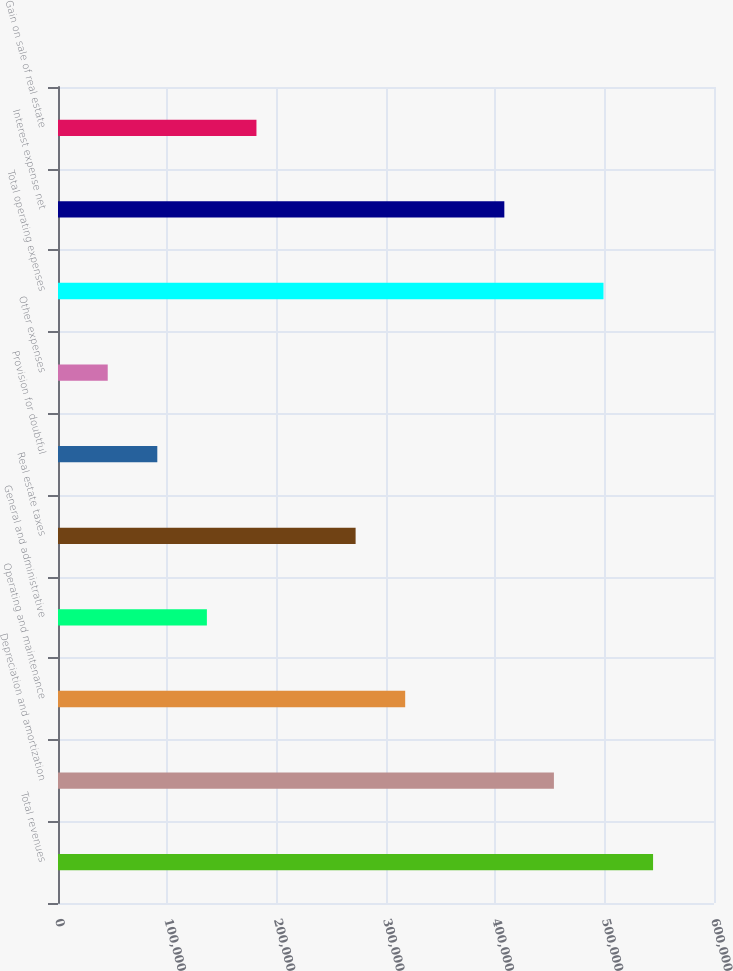Convert chart. <chart><loc_0><loc_0><loc_500><loc_500><bar_chart><fcel>Total revenues<fcel>Depreciation and amortization<fcel>Operating and maintenance<fcel>General and administrative<fcel>Real estate taxes<fcel>Provision for doubtful<fcel>Other expenses<fcel>Total operating expenses<fcel>Interest expense net<fcel>Gain on sale of real estate<nl><fcel>544268<fcel>453580<fcel>317547<fcel>136171<fcel>272203<fcel>90826.4<fcel>45482.2<fcel>498924<fcel>408236<fcel>181515<nl></chart> 